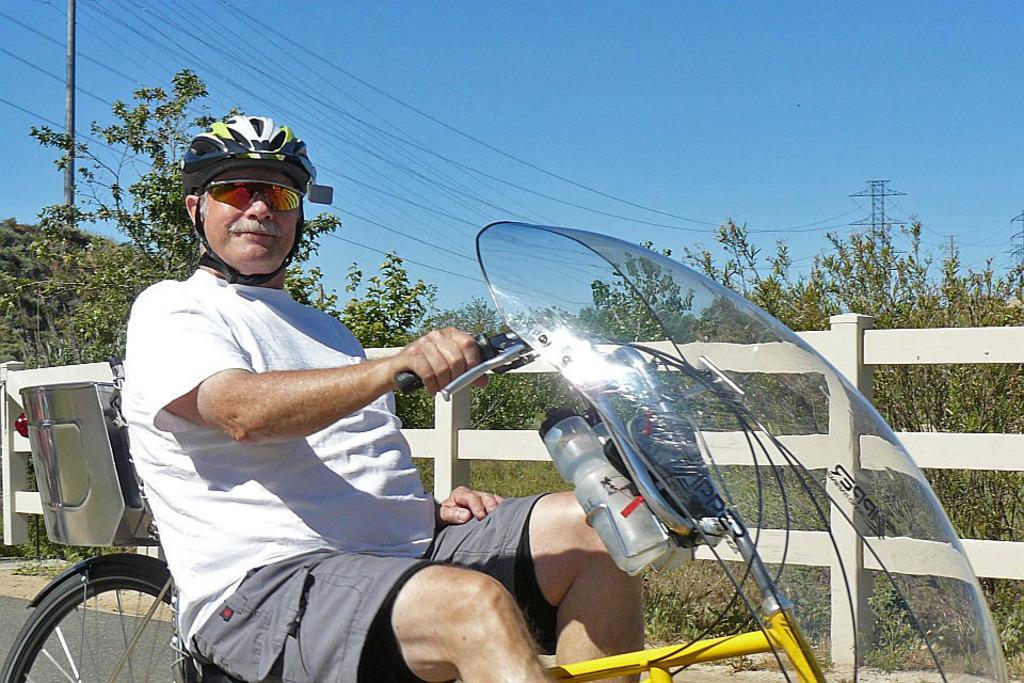Please provide a concise description of this image. This image contains a person contains a person on a vehicle having bottle in it is wearing goggles and helmet. At the back side there is a fence. Background of the image is few trees, grass and sky. Right side there are few towers. Left side there is a pole 